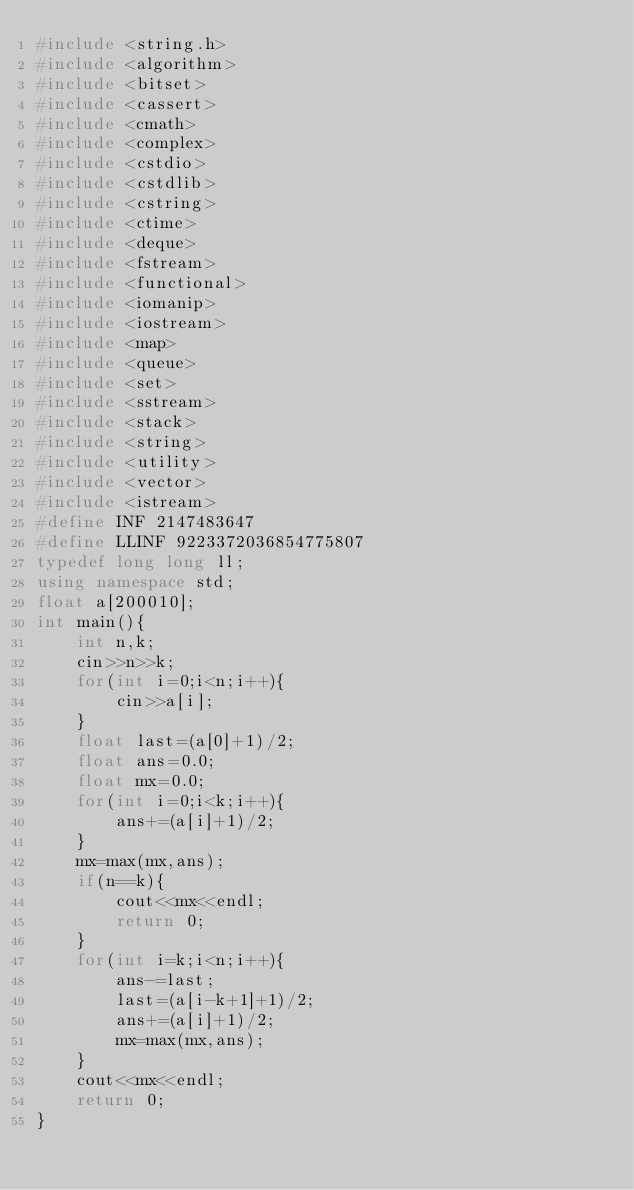<code> <loc_0><loc_0><loc_500><loc_500><_C++_>#include <string.h>
#include <algorithm>
#include <bitset>
#include <cassert>
#include <cmath>
#include <complex>
#include <cstdio>
#include <cstdlib>
#include <cstring>
#include <ctime>
#include <deque>
#include <fstream>
#include <functional>
#include <iomanip>
#include <iostream>
#include <map>
#include <queue>
#include <set>
#include <sstream>
#include <stack>
#include <string>
#include <utility>
#include <vector>
#include <istream>
#define INF 2147483647
#define LLINF 9223372036854775807
typedef long long ll;
using namespace std;
float a[200010];
int main(){
	int n,k;
	cin>>n>>k;
	for(int i=0;i<n;i++){
		cin>>a[i];
	}
	float last=(a[0]+1)/2;
	float ans=0.0;
	float mx=0.0;
	for(int i=0;i<k;i++){
		ans+=(a[i]+1)/2;
	}
	mx=max(mx,ans);
	if(n==k){
		cout<<mx<<endl;
		return 0;
	}
	for(int i=k;i<n;i++){
		ans-=last;
		last=(a[i-k+1]+1)/2;
		ans+=(a[i]+1)/2;
		mx=max(mx,ans);
	}
	cout<<mx<<endl;
	return 0;
}</code> 